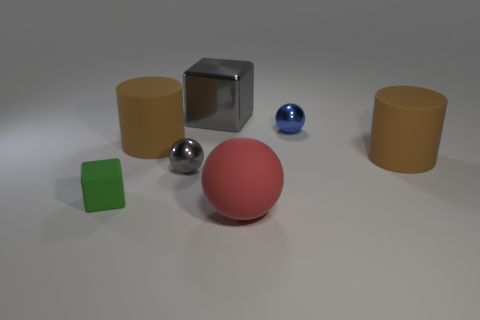Add 2 small green metal cubes. How many objects exist? 9 Subtract all cylinders. How many objects are left? 5 Subtract 0 cyan blocks. How many objects are left? 7 Subtract all blue things. Subtract all small blue shiny balls. How many objects are left? 5 Add 1 small green matte things. How many small green matte things are left? 2 Add 4 small gray metallic balls. How many small gray metallic balls exist? 5 